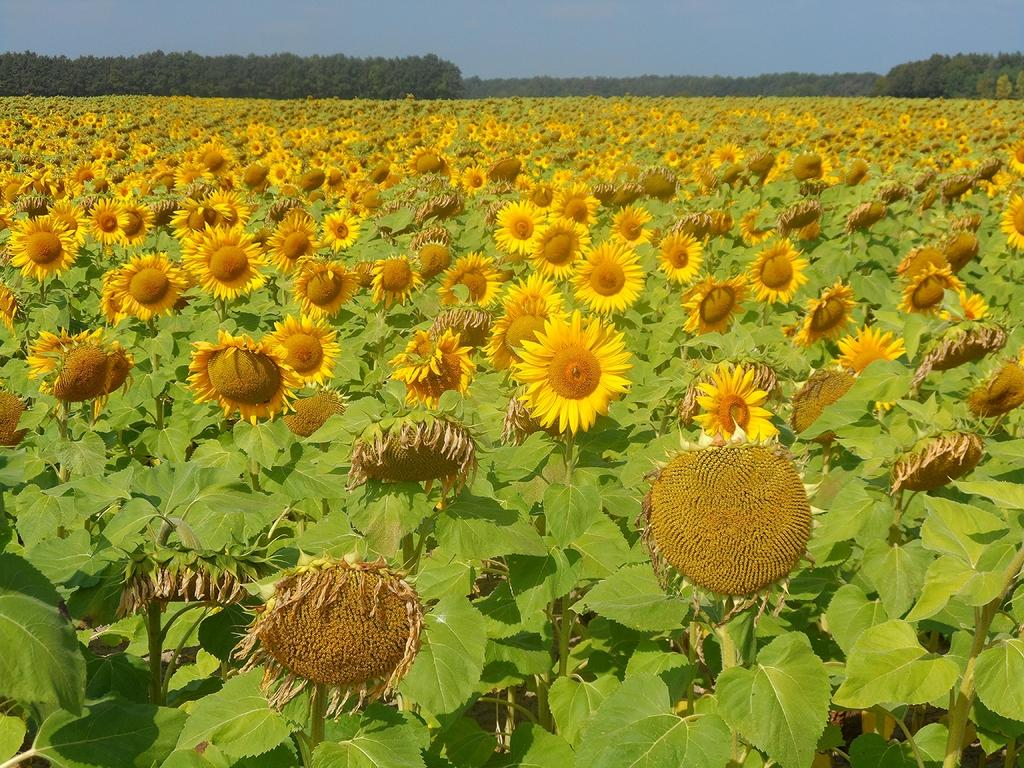What type of plants can be seen in the image? There are sunflower plants in the image. What other types of vegetation are present in the image? There are trees in the image. What can be seen in the background of the image? The sky is visible in the image. Where was the image taken? The image was taken on a farm. When was the image taken? The image was taken during the day. What type of comb is being used to groom the sunflower plants in the image? There is no comb present in the image, and sunflower plants do not require grooming. 